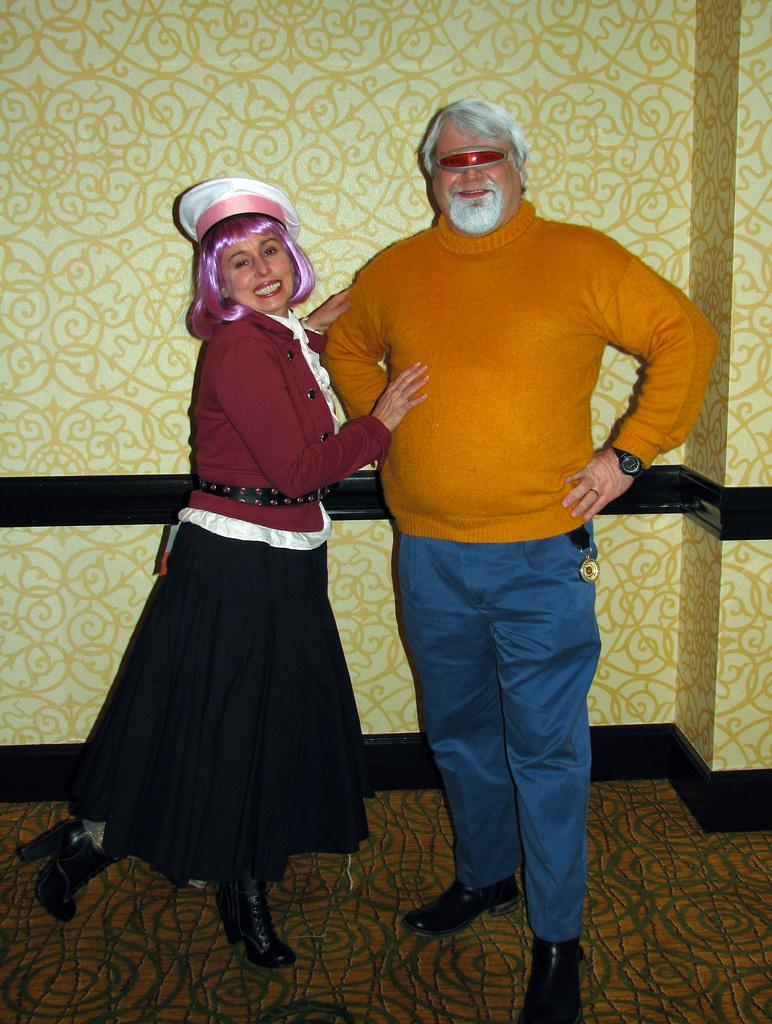Who is present in the image? There is a couple in the image. What are the couple doing in the image? The couple is standing with smiles on their faces and posing for the camera. What can be seen behind the couple? There is a wall behind the couple. What type of rule is being enforced by the couple in the image? There is no rule being enforced by the couple in the image; they are simply posing for a photo. Can you describe the clouds in the image? There are no clouds visible in the image, as it features a couple standing in front of a wall. 